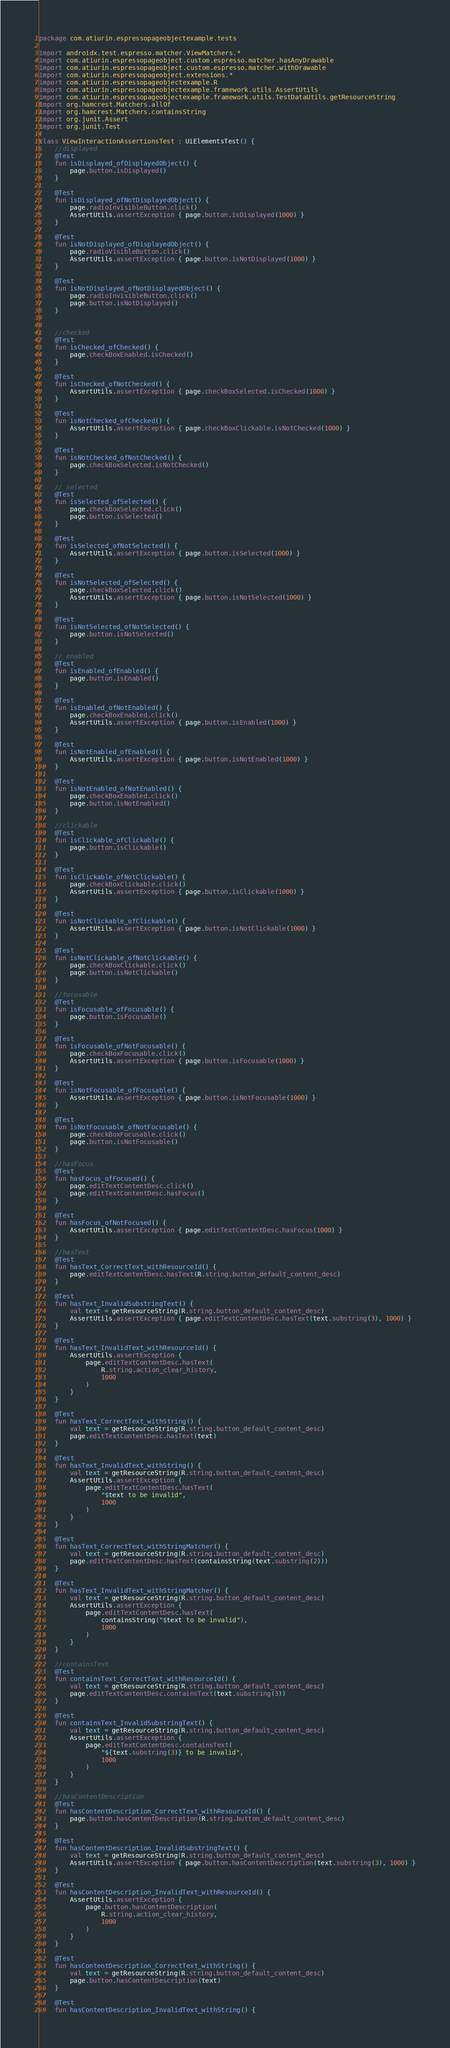Convert code to text. <code><loc_0><loc_0><loc_500><loc_500><_Kotlin_>package com.atiurin.espressopageobjectexample.tests

import androidx.test.espresso.matcher.ViewMatchers.*
import com.atiurin.espressopageobject.custom.espresso.matcher.hasAnyDrawable
import com.atiurin.espressopageobject.custom.espresso.matcher.withDrawable
import com.atiurin.espressopageobject.extensions.*
import com.atiurin.espressopageobjectexample.R
import com.atiurin.espressopageobjectexample.framework.utils.AssertUtils
import com.atiurin.espressopageobjectexample.framework.utils.TestDataUtils.getResourceString
import org.hamcrest.Matchers.allOf
import org.hamcrest.Matchers.containsString
import org.junit.Assert
import org.junit.Test

class ViewInteractionAssertionsTest : UiElementsTest() {
    //displayed
    @Test
    fun isDisplayed_ofDisplayedObject() {
        page.button.isDisplayed()
    }

    @Test
    fun isDisplayed_ofNotDisplayedObject() {
        page.radioInvisibleButton.click()
        AssertUtils.assertException { page.button.isDisplayed(1000) }
    }

    @Test
    fun isNotDisplayed_ofDisplayedObject() {
        page.radioVisibleButton.click()
        AssertUtils.assertException { page.button.isNotDisplayed(1000) }
    }

    @Test
    fun isNotDisplayed_ofNotDisplayedObject() {
        page.radioInvisibleButton.click()
        page.button.isNotDisplayed()
    }


    //checked
    @Test
    fun isChecked_ofChecked() {
        page.checkBoxEnabled.isChecked()
    }

    @Test
    fun isChecked_ofNotChecked() {
        AssertUtils.assertException { page.checkBoxSelected.isChecked(1000) }
    }

    @Test
    fun isNotChecked_ofChecked() {
        AssertUtils.assertException { page.checkBoxClickable.isNotChecked(1000) }
    }

    @Test
    fun isNotChecked_ofNotChecked() {
        page.checkBoxSelected.isNotChecked()
    }

    // selected
    @Test
    fun isSelected_ofSelected() {
        page.checkBoxSelected.click()
        page.button.isSelected()
    }

    @Test
    fun isSelected_ofNotSelected() {
        AssertUtils.assertException { page.button.isSelected(1000) }
    }

    @Test
    fun isNotSelected_ofSelected() {
        page.checkBoxSelected.click()
        AssertUtils.assertException { page.button.isNotSelected(1000) }
    }

    @Test
    fun isNotSelected_ofNotSelected() {
        page.button.isNotSelected()
    }

    // enabled
    @Test
    fun isEnabled_ofEnabled() {
        page.button.isEnabled()
    }

    @Test
    fun isEnabled_ofNotEnabled() {
        page.checkBoxEnabled.click()
        AssertUtils.assertException { page.button.isEnabled(1000) }
    }

    @Test
    fun isNotEnabled_ofEnabled() {
        AssertUtils.assertException { page.button.isNotEnabled(1000) }
    }

    @Test
    fun isNotEnabled_ofNotEnabled() {
        page.checkBoxEnabled.click()
        page.button.isNotEnabled()
    }

    //clickable
    @Test
    fun isClickable_ofClickable() {
        page.button.isClickable()
    }

    @Test
    fun isClickable_ofNotClickable() {
        page.checkBoxClickable.click()
        AssertUtils.assertException { page.button.isClickable(1000) }
    }

    @Test
    fun isNotClickable_ofClickable() {
        AssertUtils.assertException { page.button.isNotClickable(1000) }
    }

    @Test
    fun isNotClickable_ofNotClickable() {
        page.checkBoxClickable.click()
        page.button.isNotClickable()
    }

    //focusable
    @Test
    fun isFocusable_ofFocusable() {
        page.button.isFocusable()
    }

    @Test
    fun isFocusable_ofNotFocusable() {
        page.checkBoxFocusable.click()
        AssertUtils.assertException { page.button.isFocusable(1000) }
    }

    @Test
    fun isNotFocusable_ofFocusable() {
        AssertUtils.assertException { page.button.isNotFocusable(1000) }
    }

    @Test
    fun isNotFocusable_ofNotFocusable() {
        page.checkBoxFocusable.click()
        page.button.isNotFocusable()
    }

    //hasFocus
    @Test
    fun hasFocus_ofFocused() {
        page.editTextContentDesc.click()
        page.editTextContentDesc.hasFocus()
    }

    @Test
    fun hasFocus_ofNotFocused() {
        AssertUtils.assertException { page.editTextContentDesc.hasFocus(1000) }
    }

    //hasText
    @Test
    fun hasText_CorrectText_withResourceId() {
        page.editTextContentDesc.hasText(R.string.button_default_content_desc)
    }

    @Test
    fun hasText_InvalidSubstringText() {
        val text = getResourceString(R.string.button_default_content_desc)
        AssertUtils.assertException { page.editTextContentDesc.hasText(text.substring(3), 1000) }
    }

    @Test
    fun hasText_InvalidText_withResourceId() {
        AssertUtils.assertException {
            page.editTextContentDesc.hasText(
                R.string.action_clear_history,
                1000
            )
        }
    }

    @Test
    fun hasText_CorrectText_withString() {
        val text = getResourceString(R.string.button_default_content_desc)
        page.editTextContentDesc.hasText(text)
    }

    @Test
    fun hasText_InvalidText_withString() {
        val text = getResourceString(R.string.button_default_content_desc)
        AssertUtils.assertException {
            page.editTextContentDesc.hasText(
                "$text to be invalid",
                1000
            )
        }
    }

    @Test
    fun hasText_CorrectText_withStringMatcher() {
        val text = getResourceString(R.string.button_default_content_desc)
        page.editTextContentDesc.hasText(containsString(text.substring(2)))
    }

    @Test
    fun hasText_InvalidText_withStringMatcher() {
        val text = getResourceString(R.string.button_default_content_desc)
        AssertUtils.assertException {
            page.editTextContentDesc.hasText(
                containsString("$text to be invalid"),
                1000
            )
        }
    }

    //containsText
    @Test
    fun containsText_CorrectText_withResourceId() {
        val text = getResourceString(R.string.button_default_content_desc)
        page.editTextContentDesc.containsText(text.substring(3))
    }

    @Test
    fun containsText_InvalidSubstringText() {
        val text = getResourceString(R.string.button_default_content_desc)
        AssertUtils.assertException {
            page.editTextContentDesc.containsText(
                "${text.substring(3)} to be invalid",
                1000
            )
        }
    }

    //hasContentDescription
    @Test
    fun hasContentDescription_CorrectText_withResourceId() {
        page.button.hasContentDescription(R.string.button_default_content_desc)
    }

    @Test
    fun hasContentDescription_InvalidSubstringText() {
        val text = getResourceString(R.string.button_default_content_desc)
        AssertUtils.assertException { page.button.hasContentDescription(text.substring(3), 1000) }
    }

    @Test
    fun hasContentDescription_InvalidText_withResourceId() {
        AssertUtils.assertException {
            page.button.hasContentDescription(
                R.string.action_clear_history,
                1000
            )
        }
    }

    @Test
    fun hasContentDescription_CorrectText_withString() {
        val text = getResourceString(R.string.button_default_content_desc)
        page.button.hasContentDescription(text)
    }

    @Test
    fun hasContentDescription_InvalidText_withString() {</code> 